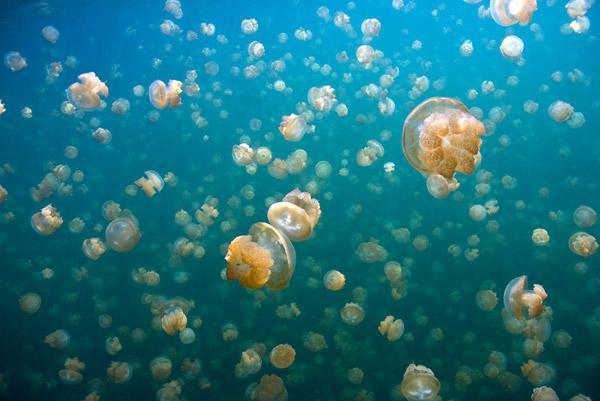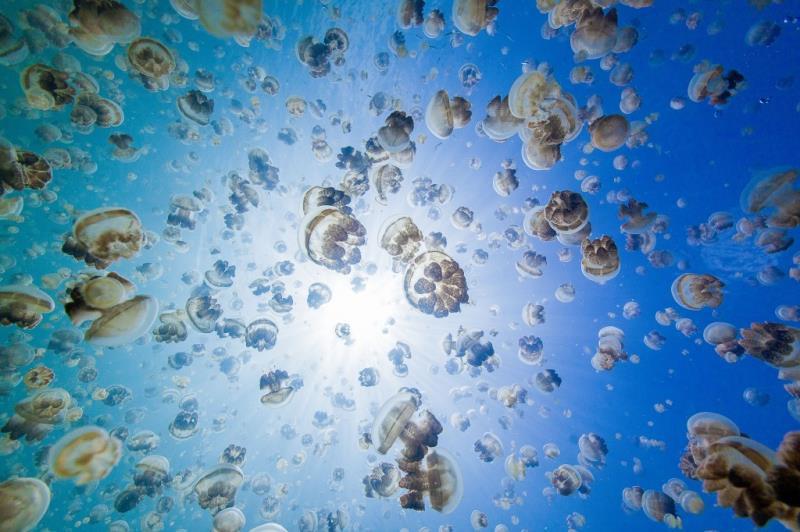The first image is the image on the left, the second image is the image on the right. For the images displayed, is the sentence "An image shows a single jellyfish trailing something frilly and foamy looking." factually correct? Answer yes or no. No. The first image is the image on the left, the second image is the image on the right. For the images shown, is this caption "At least one of the jellyfish is purplish pink in color." true? Answer yes or no. No. 